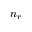<formula> <loc_0><loc_0><loc_500><loc_500>n _ { r }</formula> 